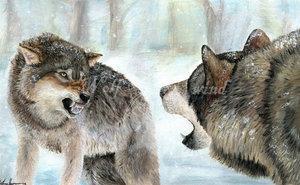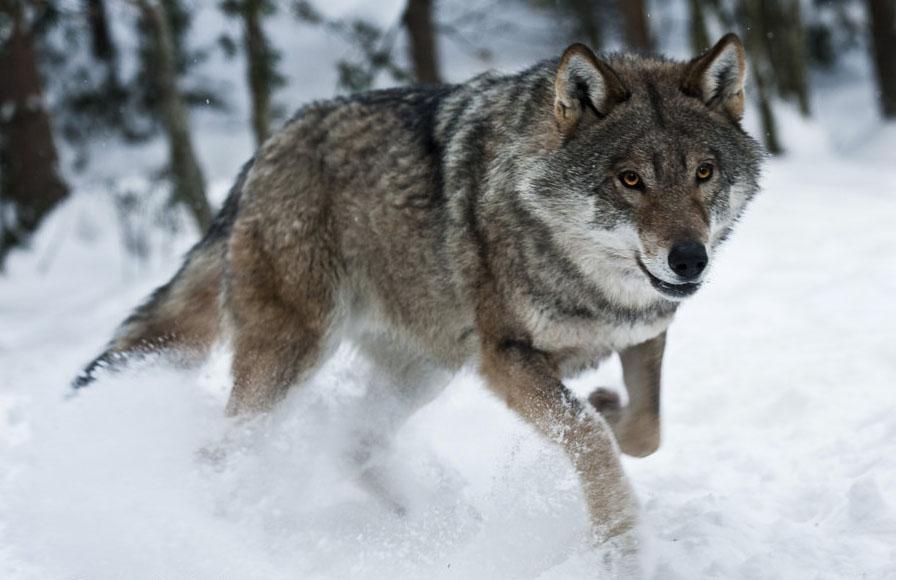The first image is the image on the left, the second image is the image on the right. Examine the images to the left and right. Is the description "There are exactly two wolves in total." accurate? Answer yes or no. No. The first image is the image on the left, the second image is the image on the right. Examine the images to the left and right. Is the description "The left image contains at least two wolves." accurate? Answer yes or no. Yes. 